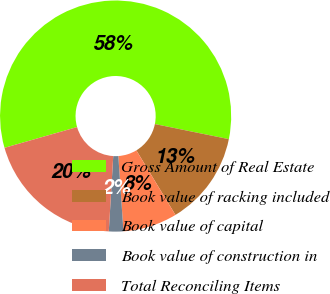<chart> <loc_0><loc_0><loc_500><loc_500><pie_chart><fcel>Gross Amount of Real Estate<fcel>Book value of racking included<fcel>Book value of capital<fcel>Book value of construction in<fcel>Total Reconciling Items<nl><fcel>57.63%<fcel>13.14%<fcel>7.58%<fcel>2.02%<fcel>19.63%<nl></chart> 